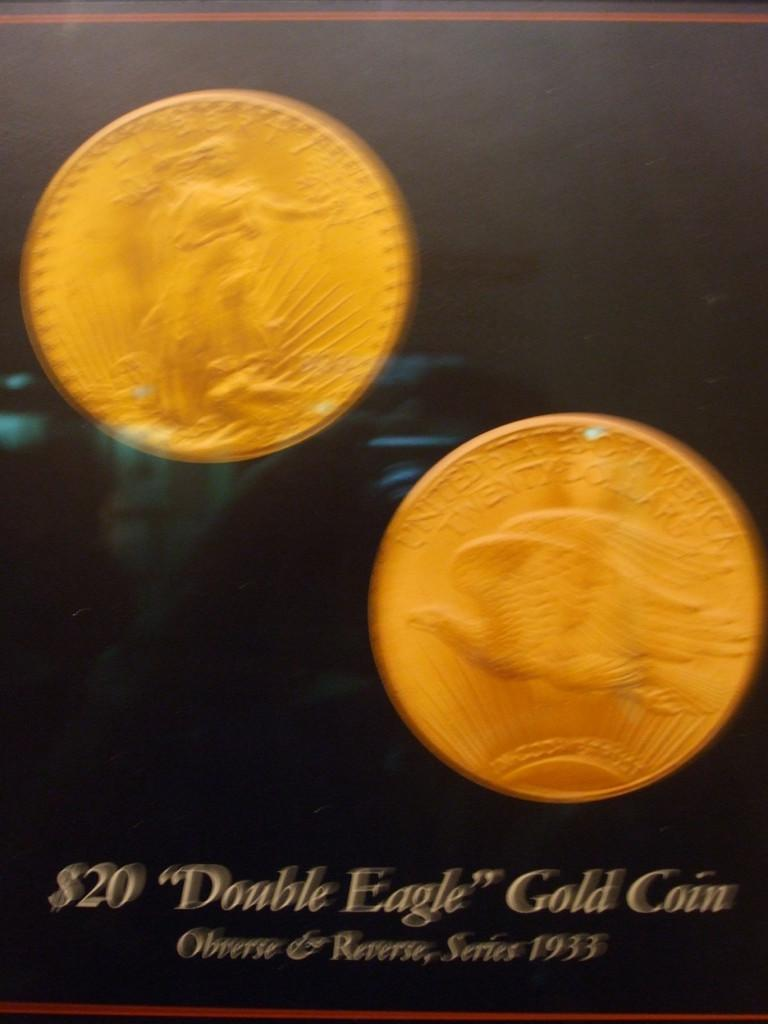<image>
Relay a brief, clear account of the picture shown. A $20 "Double Eagle" Gold coin from 1933. 